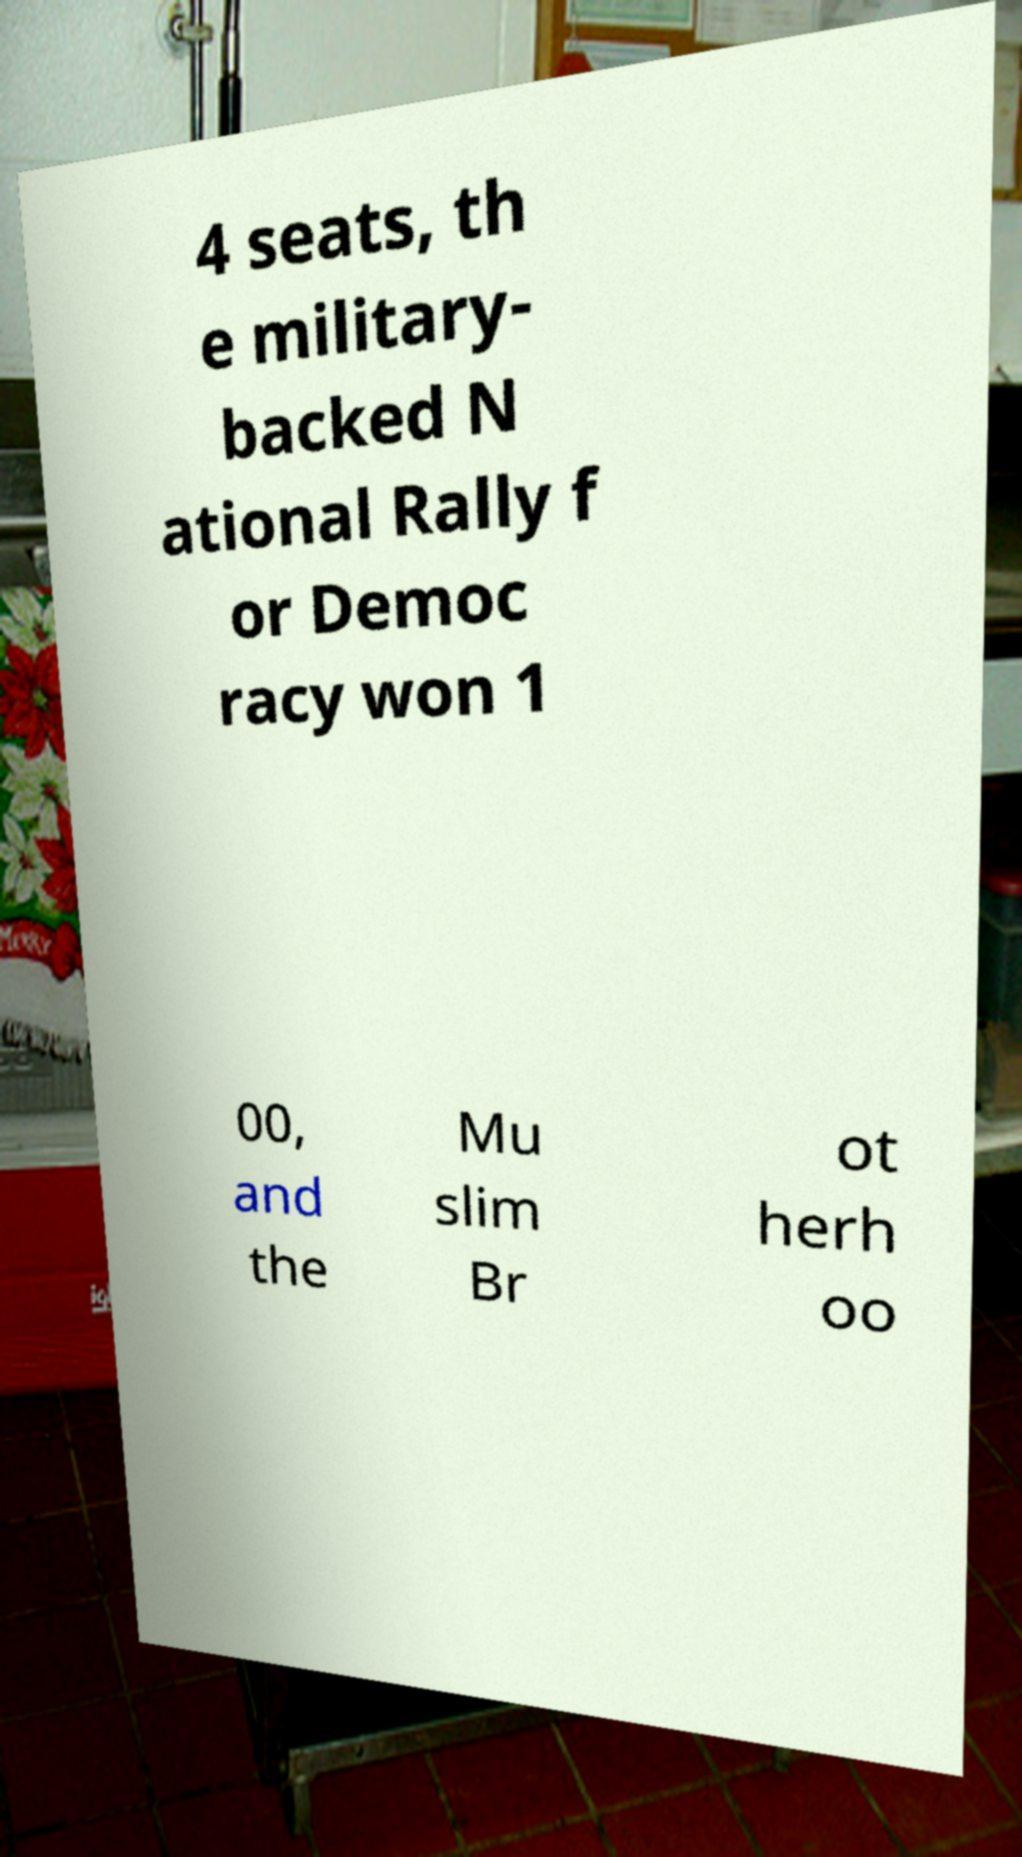What messages or text are displayed in this image? I need them in a readable, typed format. 4 seats, th e military- backed N ational Rally f or Democ racy won 1 00, and the Mu slim Br ot herh oo 